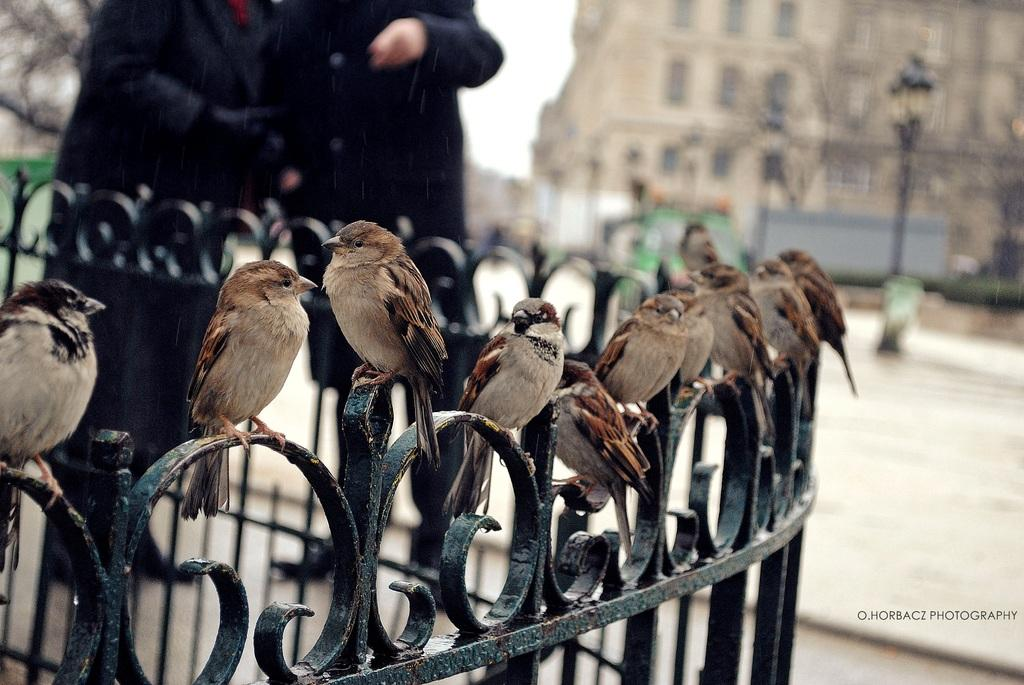What is the main subject of the image? The main subject of the image is many birds sitting. Are there any human figures in the image? Yes, there are two people standing in the image. Can you describe the background of the image? The background of the image is blurred. How many houses can be seen in the image? There are no houses present in the image; it features many birds sitting and two people standing. Is there a horse visible on the stage in the image? There is no stage or horse present in the image. 